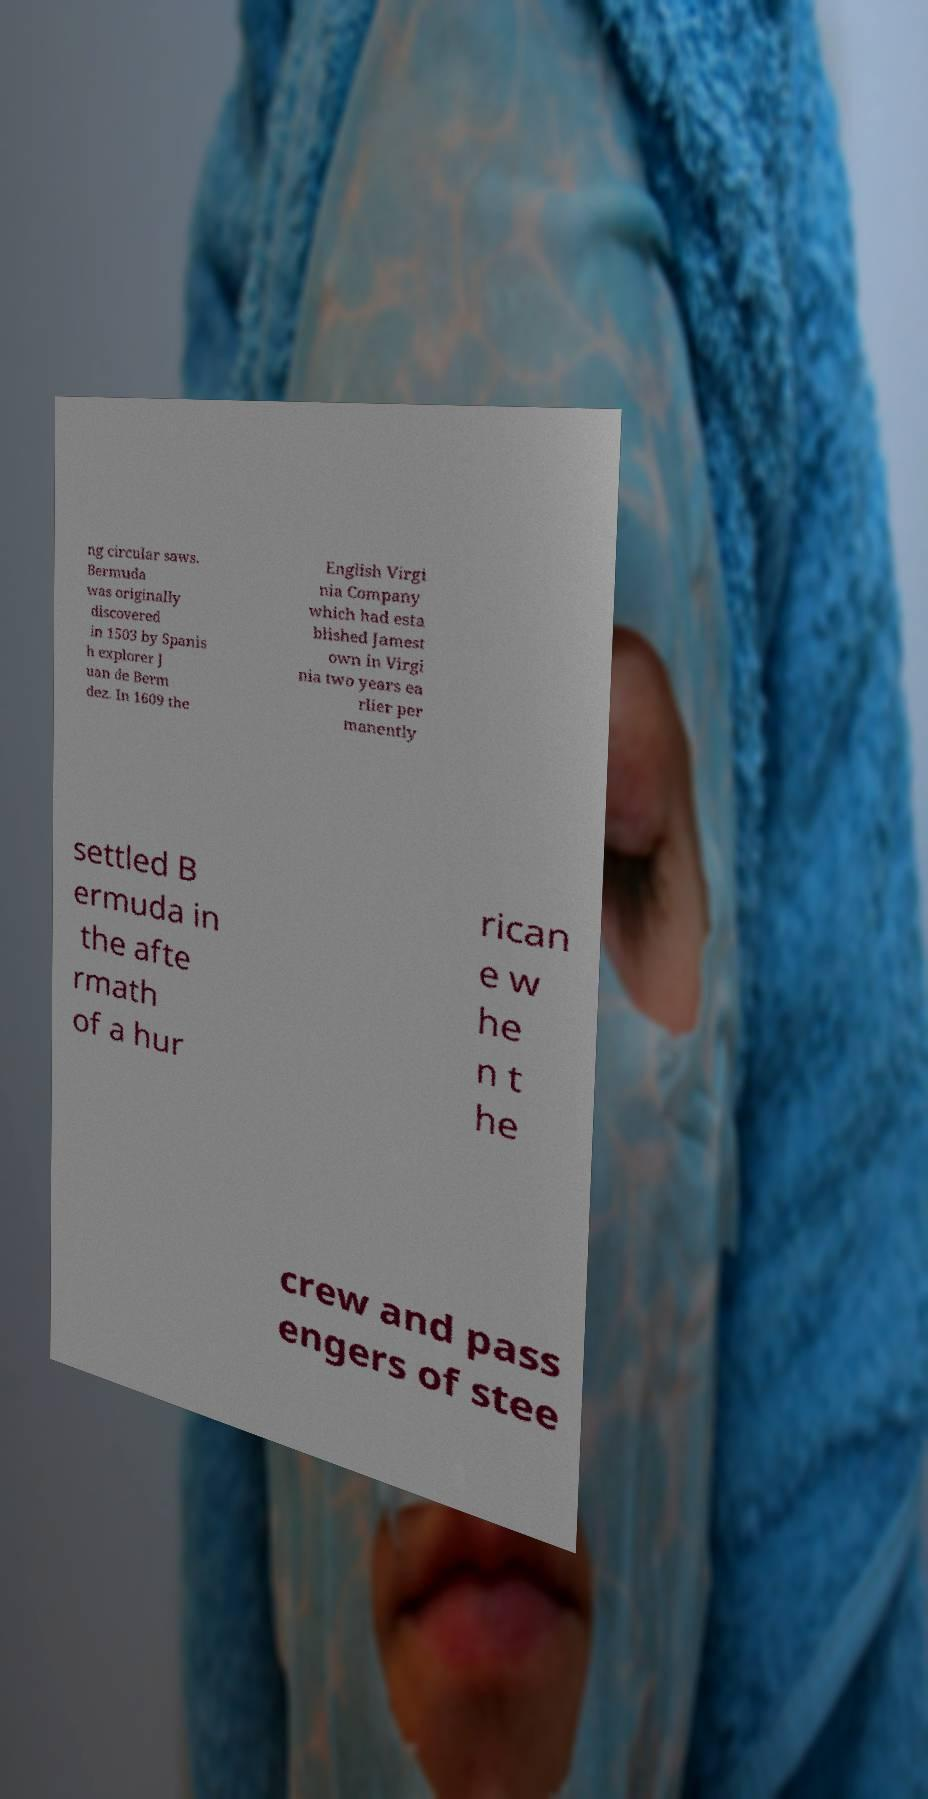There's text embedded in this image that I need extracted. Can you transcribe it verbatim? ng circular saws. Bermuda was originally discovered in 1503 by Spanis h explorer J uan de Berm dez. In 1609 the English Virgi nia Company which had esta blished Jamest own in Virgi nia two years ea rlier per manently settled B ermuda in the afte rmath of a hur rican e w he n t he crew and pass engers of stee 